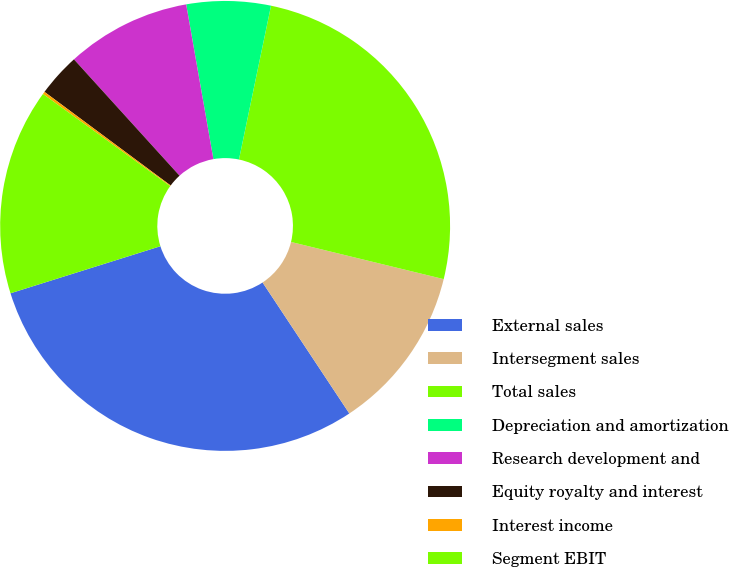<chart> <loc_0><loc_0><loc_500><loc_500><pie_chart><fcel>External sales<fcel>Intersegment sales<fcel>Total sales<fcel>Depreciation and amortization<fcel>Research development and<fcel>Equity royalty and interest<fcel>Interest income<fcel>Segment EBIT<nl><fcel>29.47%<fcel>11.89%<fcel>25.53%<fcel>6.04%<fcel>8.96%<fcel>3.11%<fcel>0.18%<fcel>14.82%<nl></chart> 